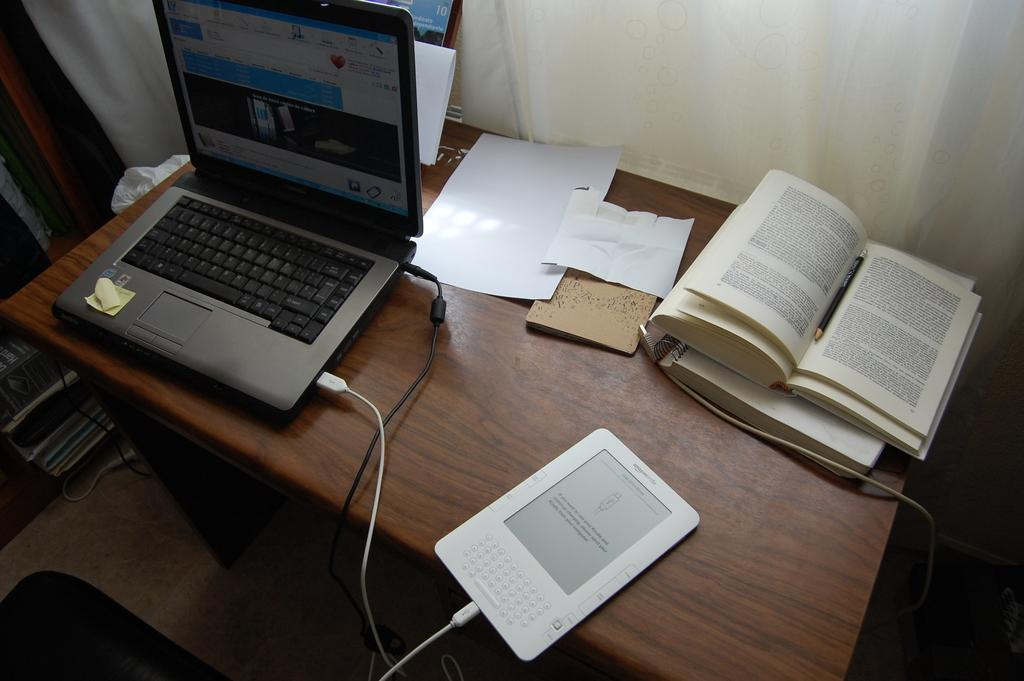What is the main object in the center of the image? There is a table in the center of the image. What electronic device is on the table? A laptop is present on the table. What else can be seen on the table besides the laptop? There is a book and a tab on the table. What can be seen in the background of the image? There is a curtain in the background of the image. What type of peace treaty is being signed on the table in the image? There is no peace treaty or any indication of signing a document in the image. 